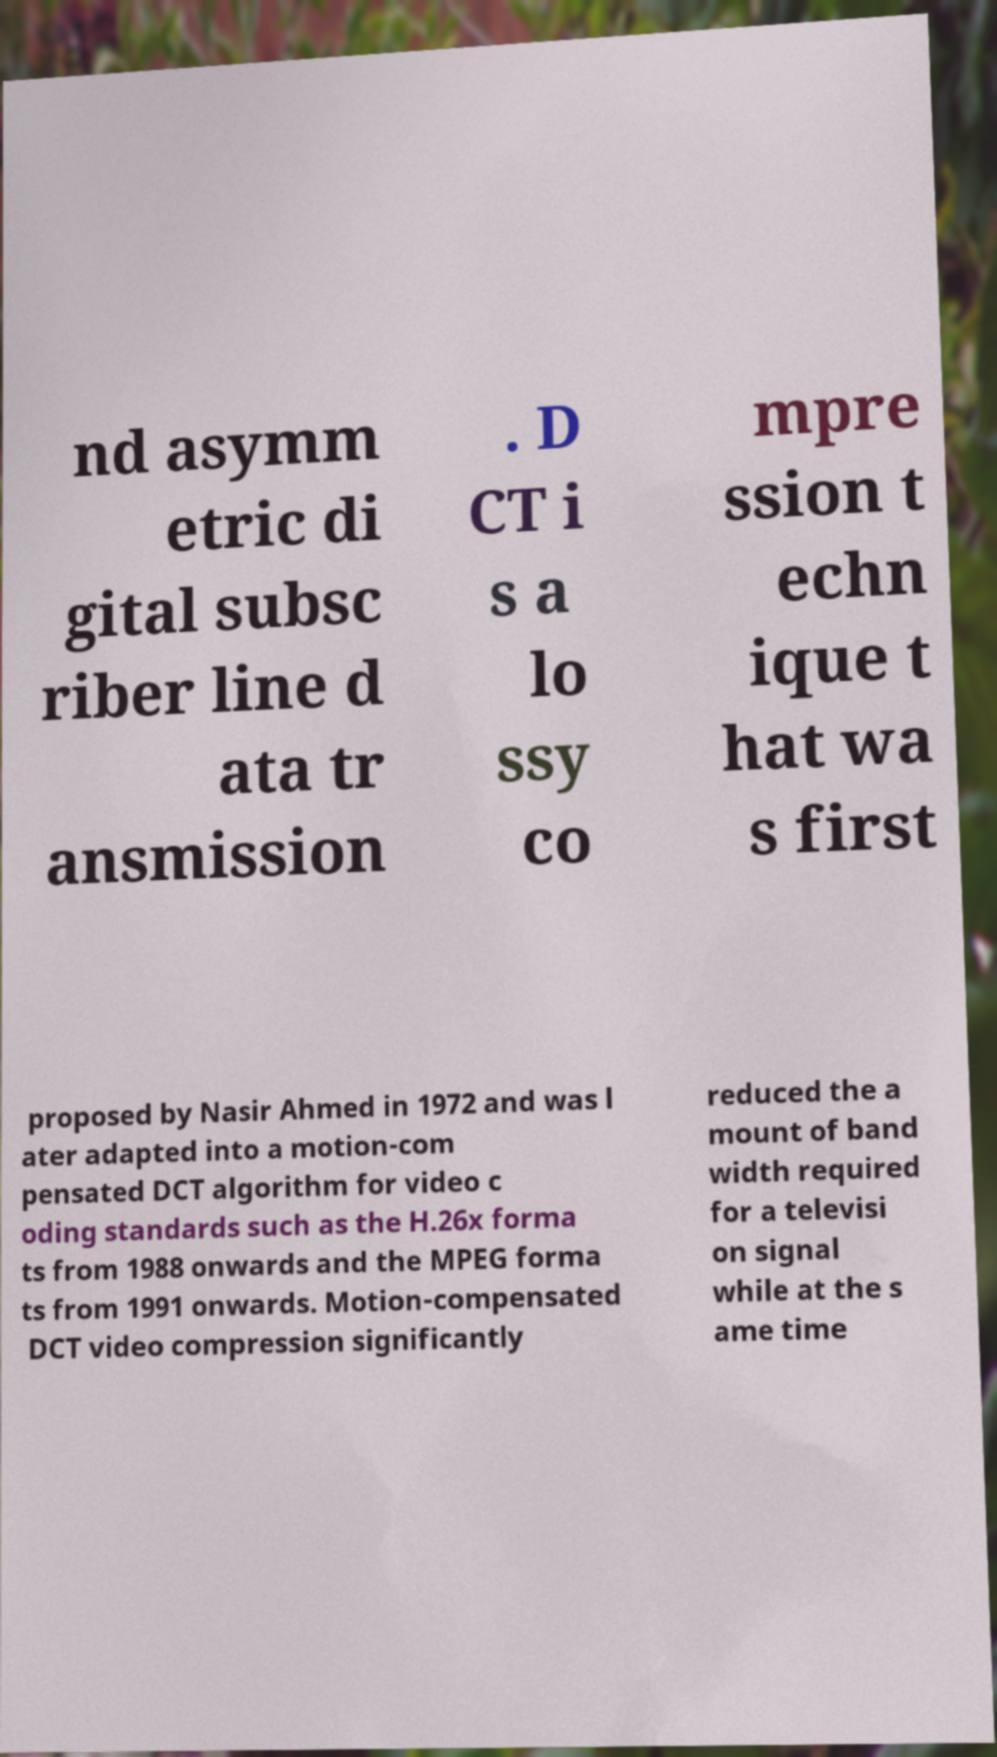Please identify and transcribe the text found in this image. nd asymm etric di gital subsc riber line d ata tr ansmission . D CT i s a lo ssy co mpre ssion t echn ique t hat wa s first proposed by Nasir Ahmed in 1972 and was l ater adapted into a motion-com pensated DCT algorithm for video c oding standards such as the H.26x forma ts from 1988 onwards and the MPEG forma ts from 1991 onwards. Motion-compensated DCT video compression significantly reduced the a mount of band width required for a televisi on signal while at the s ame time 